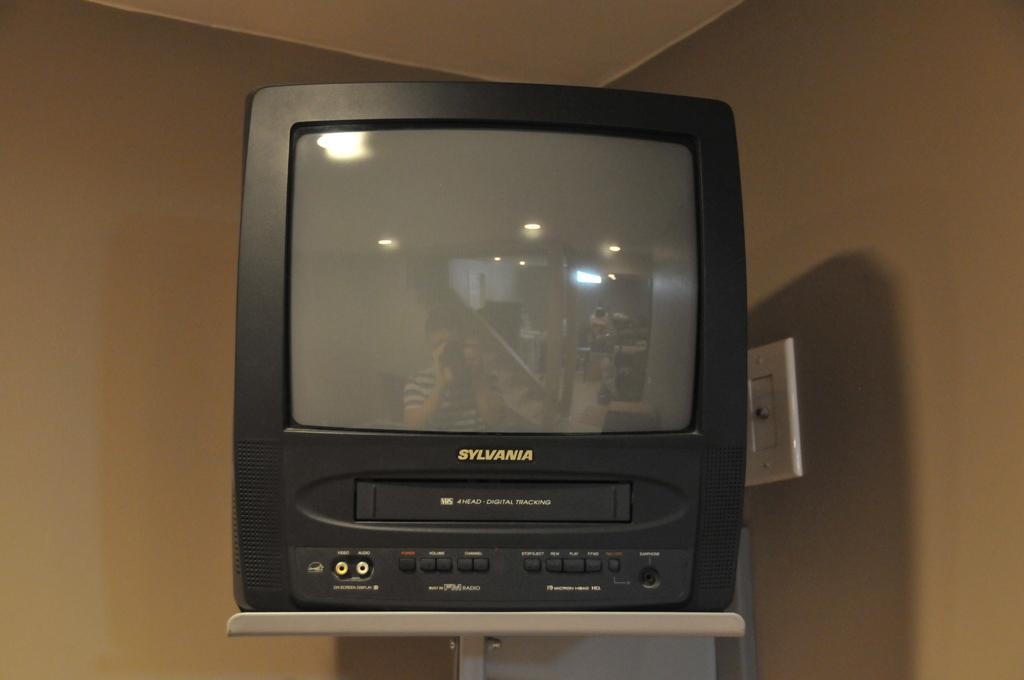<image>
Give a short and clear explanation of the subsequent image. A sylvania television sits upon a shelf in the corner of a room. 